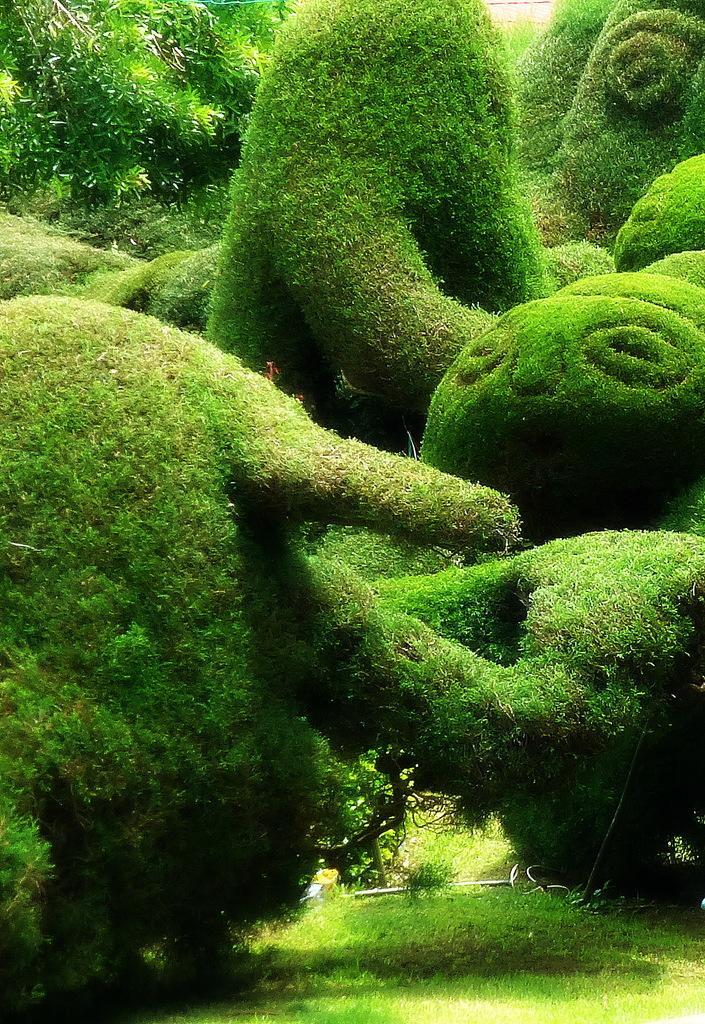In one or two sentences, can you explain what this image depicts? In the image there are bushes in different shapes. And on the ground there is grass. 